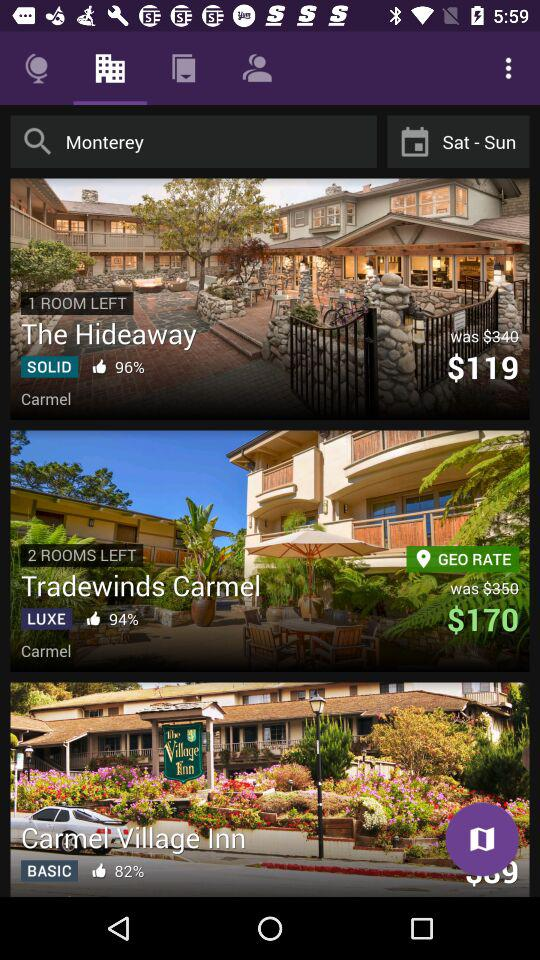What is the like percentage for "Carmel Village Inn"? The like percentage for "Carmel Village Inn" is 82. 